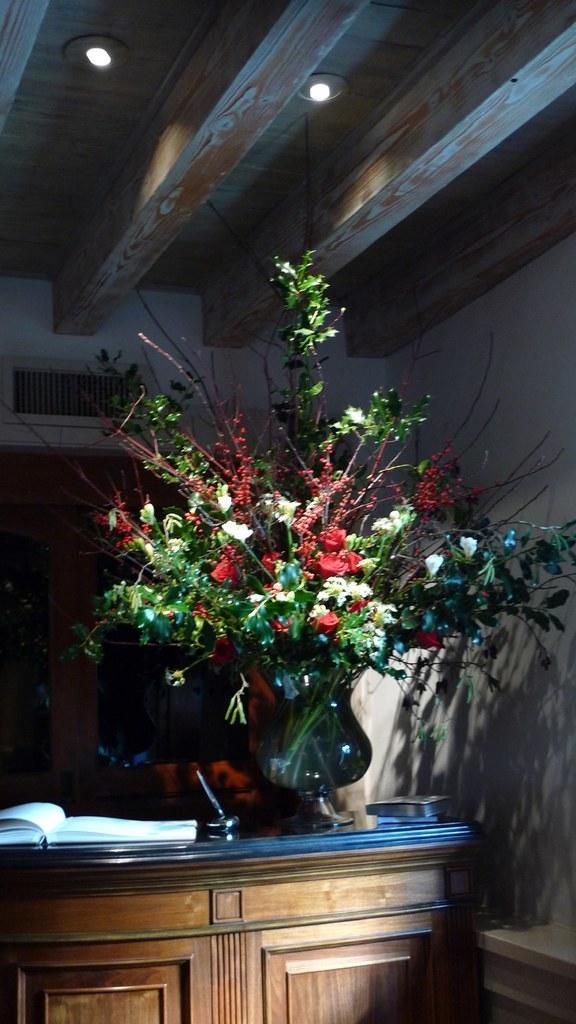Please provide a concise description of this image. In the foreground of the picture there are desk, book and a flower vase. At the top there are lights to the ceiling. In the background there is a door. On the right it is wall painted white. 